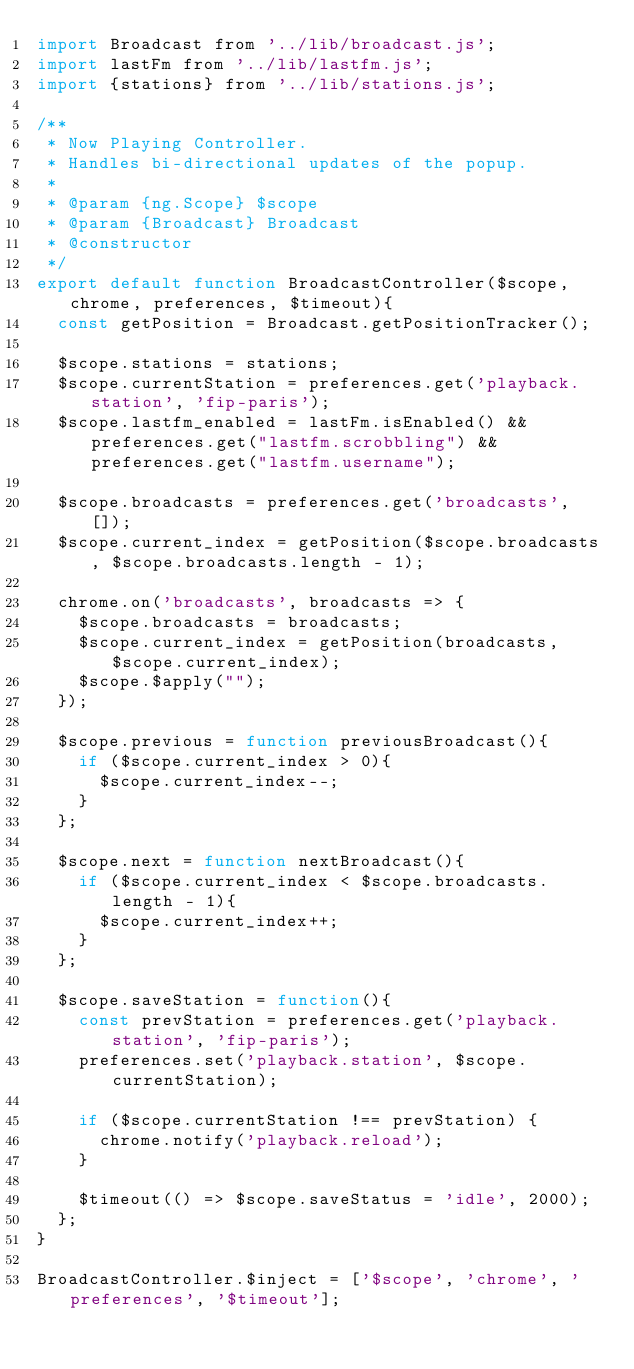<code> <loc_0><loc_0><loc_500><loc_500><_JavaScript_>import Broadcast from '../lib/broadcast.js';
import lastFm from '../lib/lastfm.js';
import {stations} from '../lib/stations.js';

/**
 * Now Playing Controller.
 * Handles bi-directional updates of the popup.
 *
 * @param {ng.Scope} $scope
 * @param {Broadcast} Broadcast
 * @constructor
 */
export default function BroadcastController($scope, chrome, preferences, $timeout){
  const getPosition = Broadcast.getPositionTracker();

  $scope.stations = stations;
  $scope.currentStation = preferences.get('playback.station', 'fip-paris');
  $scope.lastfm_enabled = lastFm.isEnabled() && preferences.get("lastfm.scrobbling") && preferences.get("lastfm.username");

  $scope.broadcasts = preferences.get('broadcasts', []);
  $scope.current_index = getPosition($scope.broadcasts, $scope.broadcasts.length - 1);

  chrome.on('broadcasts', broadcasts => {
    $scope.broadcasts = broadcasts;
    $scope.current_index = getPosition(broadcasts, $scope.current_index);
    $scope.$apply("");
  });

  $scope.previous = function previousBroadcast(){
    if ($scope.current_index > 0){
      $scope.current_index--;
    }
  };

  $scope.next = function nextBroadcast(){
    if ($scope.current_index < $scope.broadcasts.length - 1){
      $scope.current_index++;
    }
  };

  $scope.saveStation = function(){
    const prevStation = preferences.get('playback.station', 'fip-paris');
    preferences.set('playback.station', $scope.currentStation);

    if ($scope.currentStation !== prevStation) {
      chrome.notify('playback.reload');
    }

    $timeout(() => $scope.saveStatus = 'idle', 2000);
  };
}

BroadcastController.$inject = ['$scope', 'chrome', 'preferences', '$timeout'];
</code> 